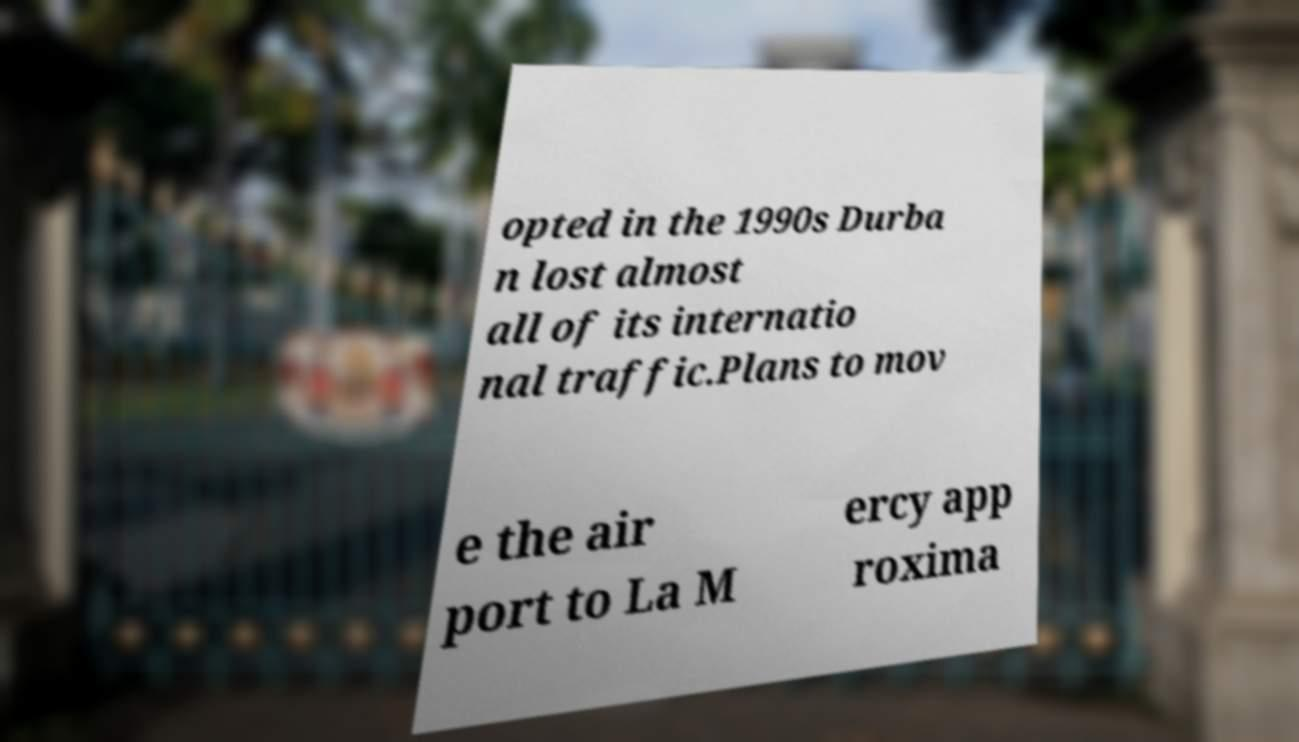For documentation purposes, I need the text within this image transcribed. Could you provide that? opted in the 1990s Durba n lost almost all of its internatio nal traffic.Plans to mov e the air port to La M ercy app roxima 